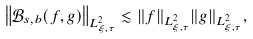<formula> <loc_0><loc_0><loc_500><loc_500>\left \| \mathcal { B } _ { s , b } ( f , g ) \right \| _ { L ^ { 2 } _ { \xi , \tau } } \lesssim \| f \| _ { L ^ { 2 } _ { \xi , \tau } } \| g \| _ { L ^ { 2 } _ { \xi , \tau } } ,</formula> 